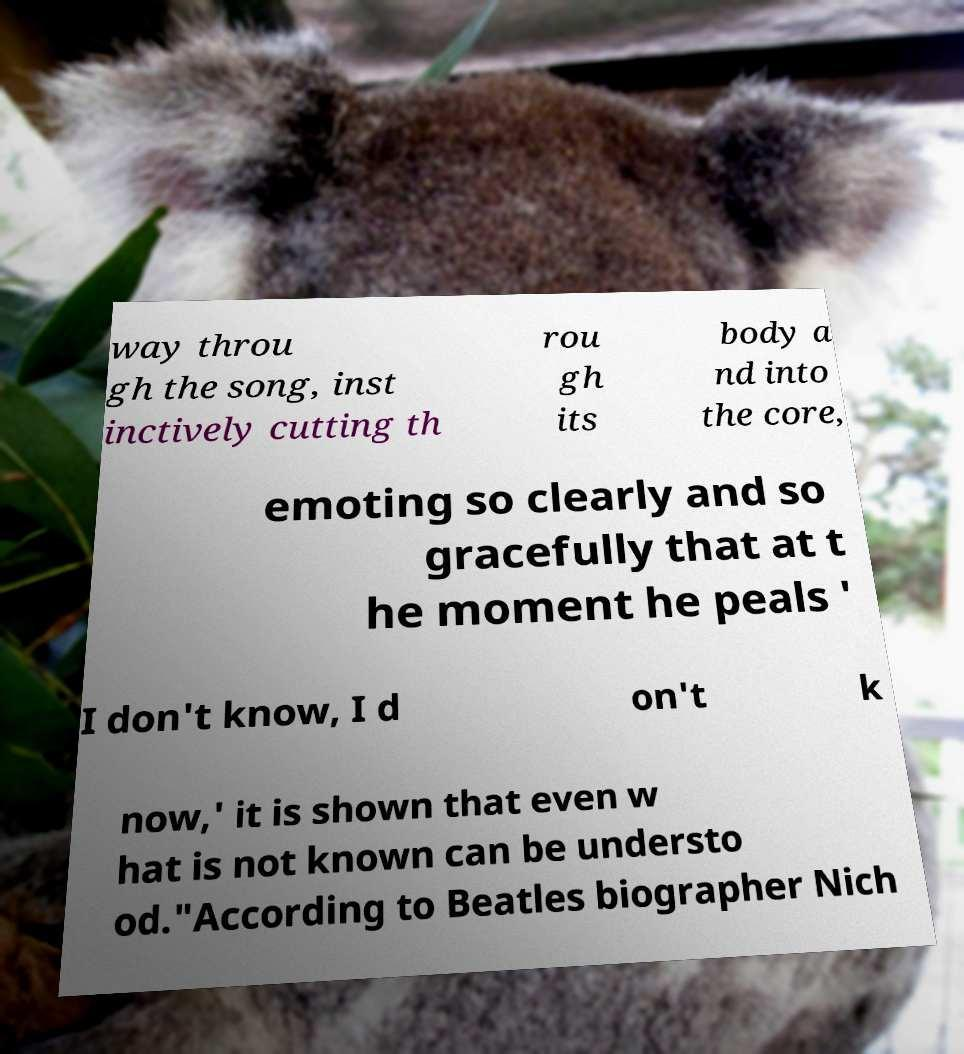Can you accurately transcribe the text from the provided image for me? way throu gh the song, inst inctively cutting th rou gh its body a nd into the core, emoting so clearly and so gracefully that at t he moment he peals ' I don't know, I d on't k now,' it is shown that even w hat is not known can be understo od."According to Beatles biographer Nich 